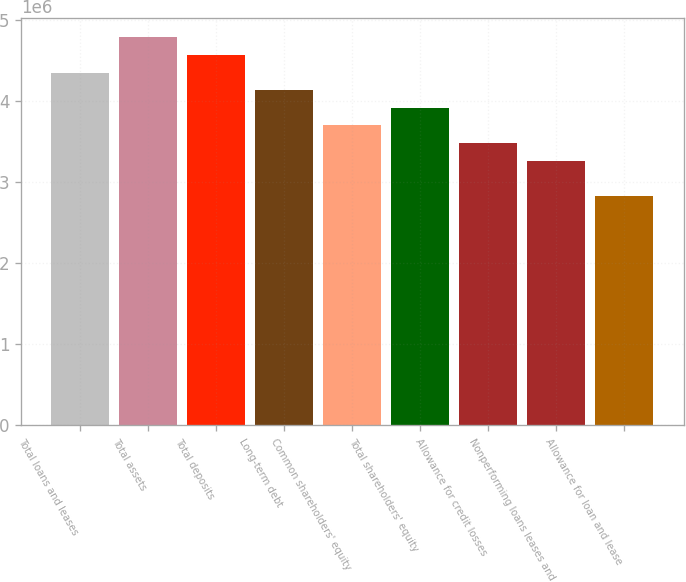<chart> <loc_0><loc_0><loc_500><loc_500><bar_chart><fcel>Total loans and leases<fcel>Total assets<fcel>Total deposits<fcel>Long-term debt<fcel>Common shareholders' equity<fcel>Total shareholders' equity<fcel>Allowance for credit losses<fcel>Nonperforming loans leases and<fcel>Allowance for loan and lease<nl><fcel>4.34662e+06<fcel>4.78129e+06<fcel>4.56395e+06<fcel>4.12929e+06<fcel>3.69463e+06<fcel>3.91196e+06<fcel>3.4773e+06<fcel>3.25997e+06<fcel>2.82531e+06<nl></chart> 